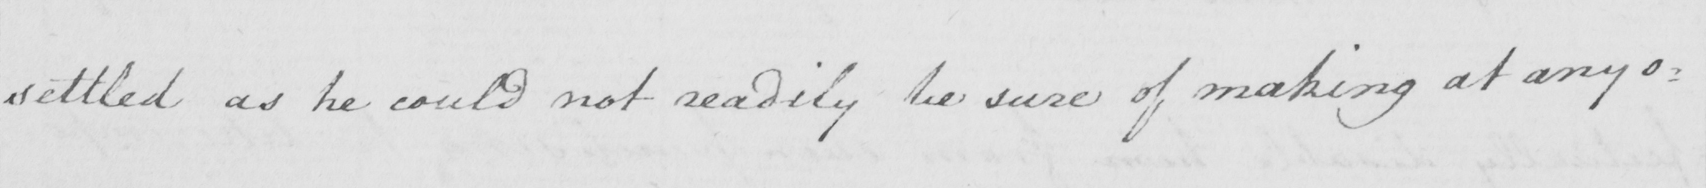Can you tell me what this handwritten text says? settled as he could not readily be sure of making at any o= 